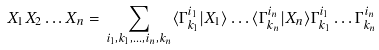<formula> <loc_0><loc_0><loc_500><loc_500>X _ { 1 } X _ { 2 } \dots X _ { n } = \, \sum _ { i _ { 1 } , k _ { 1 } , \dots , i _ { n } , k _ { n } } \langle \Gamma _ { k _ { 1 } } ^ { i _ { 1 } } | X _ { 1 } \rangle \dots \langle \Gamma _ { k _ { n } } ^ { i _ { n } } | X _ { n } \rangle \Gamma _ { k _ { 1 } } ^ { i _ { 1 } } \dots \Gamma _ { k _ { n } } ^ { i _ { n } }</formula> 